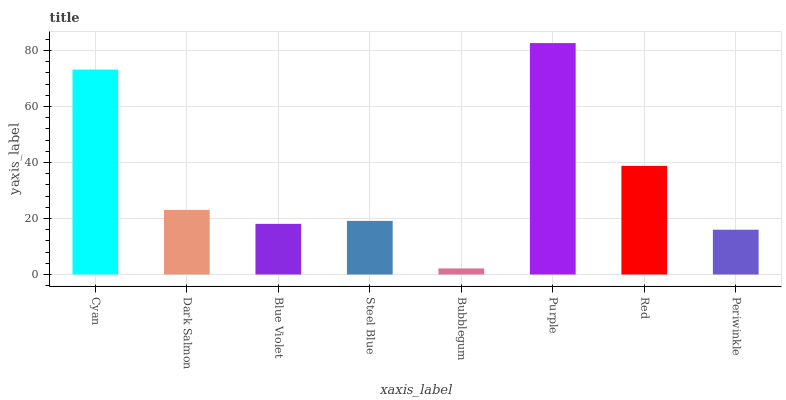Is Bubblegum the minimum?
Answer yes or no. Yes. Is Purple the maximum?
Answer yes or no. Yes. Is Dark Salmon the minimum?
Answer yes or no. No. Is Dark Salmon the maximum?
Answer yes or no. No. Is Cyan greater than Dark Salmon?
Answer yes or no. Yes. Is Dark Salmon less than Cyan?
Answer yes or no. Yes. Is Dark Salmon greater than Cyan?
Answer yes or no. No. Is Cyan less than Dark Salmon?
Answer yes or no. No. Is Dark Salmon the high median?
Answer yes or no. Yes. Is Steel Blue the low median?
Answer yes or no. Yes. Is Purple the high median?
Answer yes or no. No. Is Purple the low median?
Answer yes or no. No. 